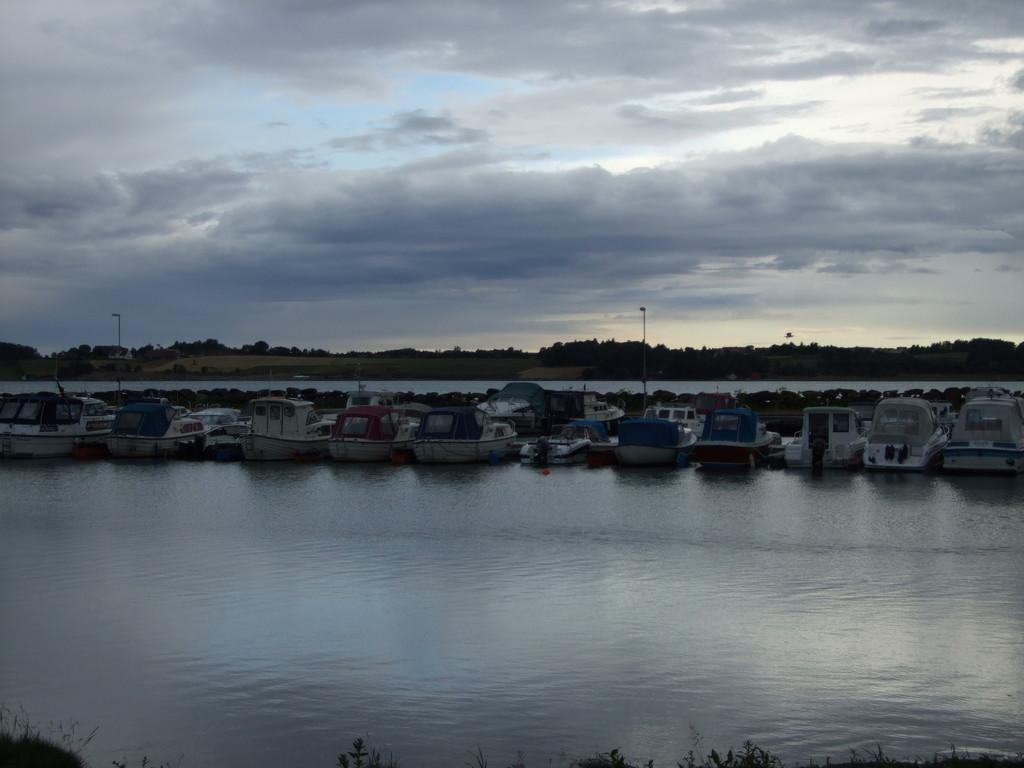What type of vehicles can be seen on the water in the image? There are boats on the water in the image. What type of natural vegetation is visible in the image? There are trees visible in the image. What type of illumination is present in the image? There are lights in the image. What type of structures can be seen in the image? There are poles in the image. What is visible in the background of the image? The sky is visible in the background of the image. How does the ocean help the boats in the image? The image does not depict an ocean; it shows boats on water, which could be a river, lake, or another body of water. Additionally, the image does not show any interaction between the boats and the water, so it is not possible to determine how the water might help the boats. 